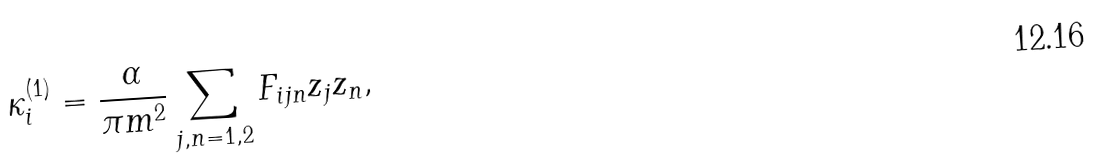Convert formula to latex. <formula><loc_0><loc_0><loc_500><loc_500>\kappa _ { i } ^ { ( 1 ) } = \frac { \alpha } { \pi m ^ { 2 } } \sum _ { j , n = 1 , 2 } F _ { i j n } z _ { j } z _ { n } ,</formula> 